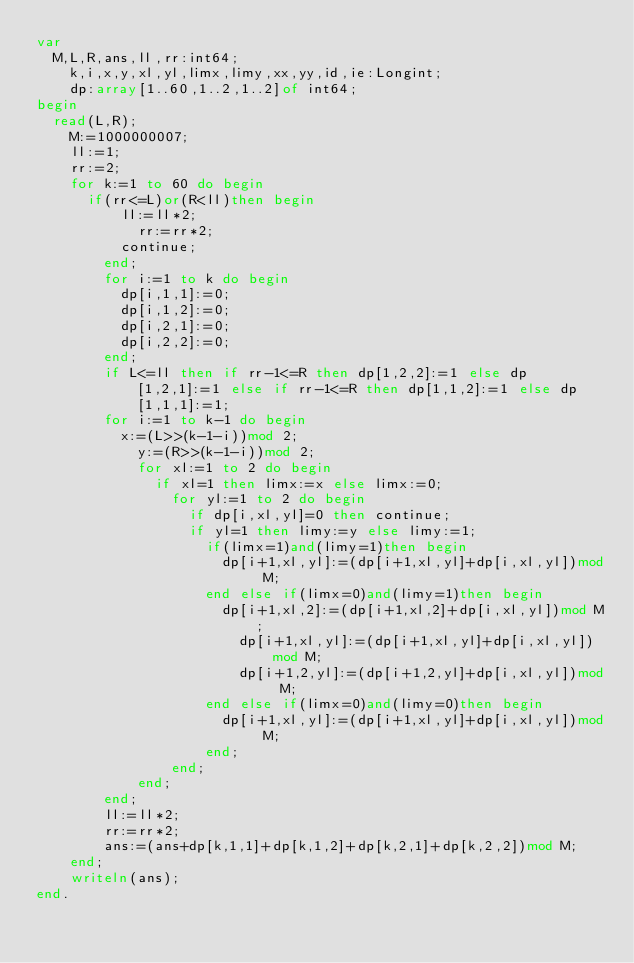<code> <loc_0><loc_0><loc_500><loc_500><_Pascal_>var
	M,L,R,ans,ll,rr:int64;
    k,i,x,y,xl,yl,limx,limy,xx,yy,id,ie:Longint;
    dp:array[1..60,1..2,1..2]of int64;
begin
	read(L,R);
    M:=1000000007;
    ll:=1;
    rr:=2;
    for k:=1 to 60 do begin
    	if(rr<=L)or(R<ll)then begin
        	ll:=ll*2;
            rr:=rr*2;
        	continue;
        end;
        for i:=1 to k do begin
        	dp[i,1,1]:=0;
        	dp[i,1,2]:=0;
        	dp[i,2,1]:=0;
        	dp[i,2,2]:=0;
        end;
        if L<=ll then if rr-1<=R then dp[1,2,2]:=1 else dp[1,2,1]:=1 else if rr-1<=R then dp[1,1,2]:=1 else dp[1,1,1]:=1;
        for i:=1 to k-1 do begin
        	x:=(L>>(k-1-i))mod 2;
            y:=(R>>(k-1-i))mod 2;
            for xl:=1 to 2 do begin
            	if xl=1 then limx:=x else limx:=0;
                for yl:=1 to 2 do begin
                	if dp[i,xl,yl]=0 then continue;
                	if yl=1 then limy:=y else limy:=1;
                    if(limx=1)and(limy=1)then begin
                    	dp[i+1,xl,yl]:=(dp[i+1,xl,yl]+dp[i,xl,yl])mod M;
                    end else if(limx=0)and(limy=1)then begin
                    	dp[i+1,xl,2]:=(dp[i+1,xl,2]+dp[i,xl,yl])mod M;
                        dp[i+1,xl,yl]:=(dp[i+1,xl,yl]+dp[i,xl,yl])mod M;
                        dp[i+1,2,yl]:=(dp[i+1,2,yl]+dp[i,xl,yl])mod M;
                    end else if(limx=0)and(limy=0)then begin
                    	dp[i+1,xl,yl]:=(dp[i+1,xl,yl]+dp[i,xl,yl])mod M;
                    end;
                end;
            end;
        end;
        ll:=ll*2;
        rr:=rr*2;
        ans:=(ans+dp[k,1,1]+dp[k,1,2]+dp[k,2,1]+dp[k,2,2])mod M;
    end;
    writeln(ans);
end.</code> 